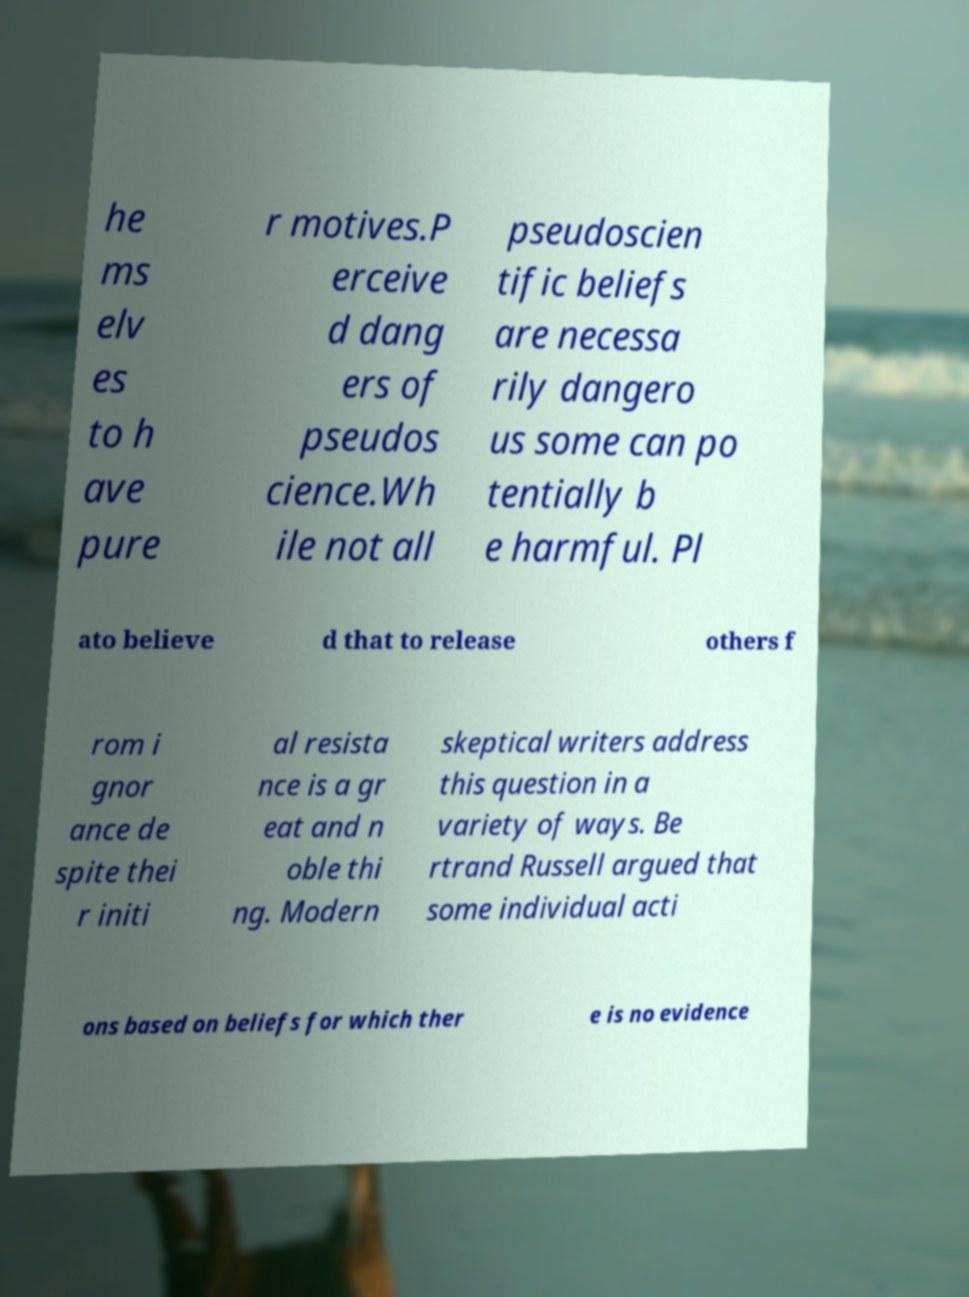Could you extract and type out the text from this image? he ms elv es to h ave pure r motives.P erceive d dang ers of pseudos cience.Wh ile not all pseudoscien tific beliefs are necessa rily dangero us some can po tentially b e harmful. Pl ato believe d that to release others f rom i gnor ance de spite thei r initi al resista nce is a gr eat and n oble thi ng. Modern skeptical writers address this question in a variety of ways. Be rtrand Russell argued that some individual acti ons based on beliefs for which ther e is no evidence 